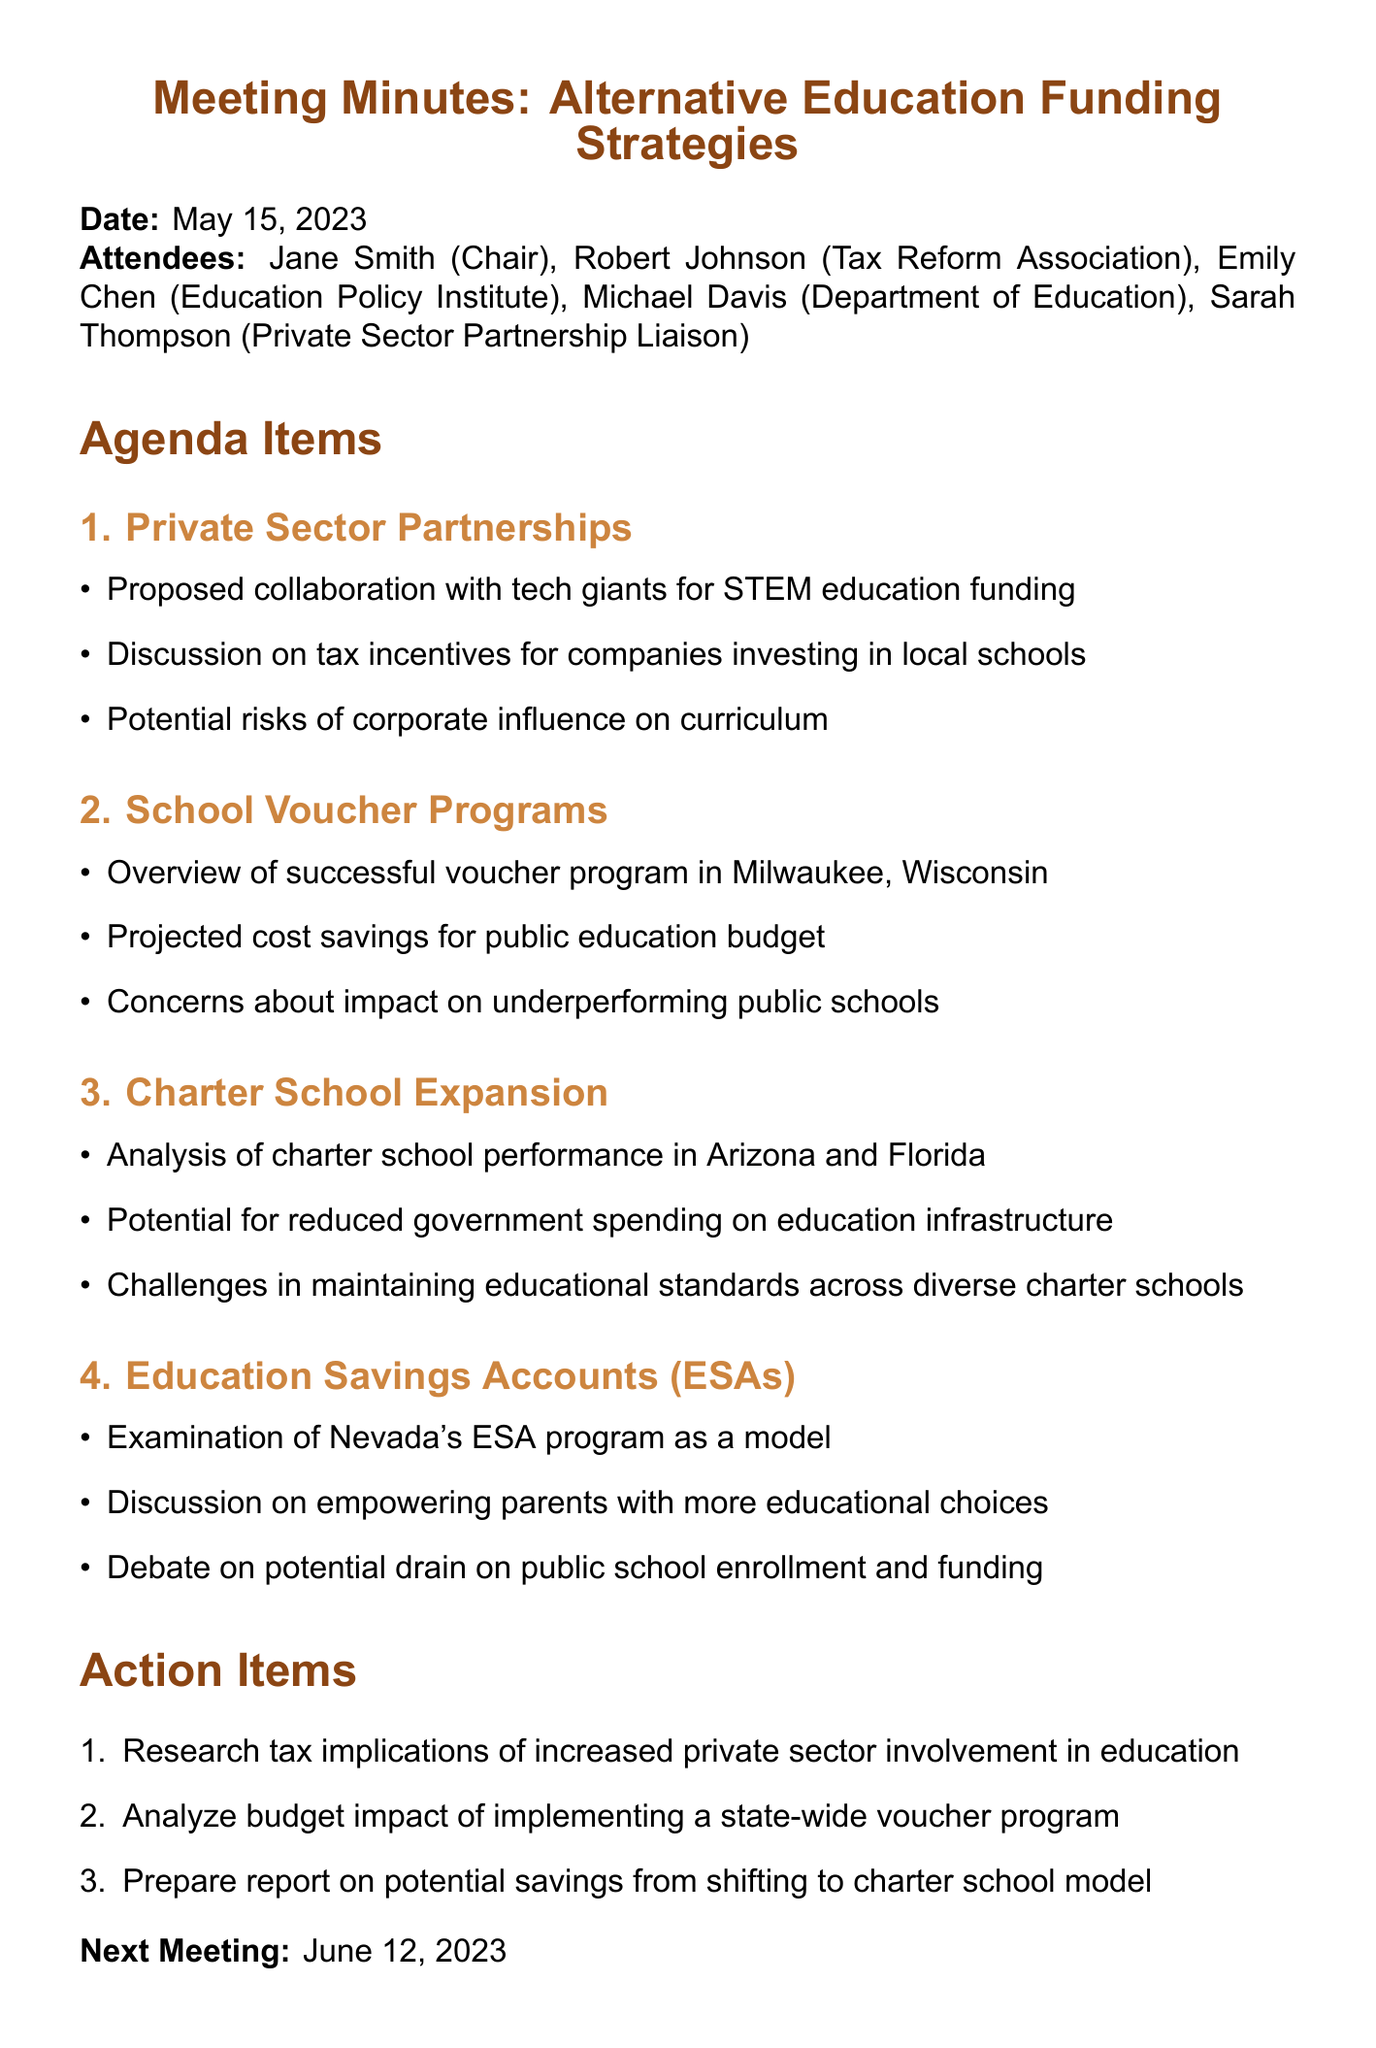What is the date of the meeting? The date of the meeting is stated clearly in the minutes.
Answer: May 15, 2023 Who is the chair of the meeting? The chair is mentioned in the list of attendees.
Answer: Jane Smith What is one of the proposed collaborations with tech companies? Specific proposals are listed under the Private Sector Partnerships section.
Answer: STEM education funding What successful voucher program is mentioned? Successful examples are provided in the School Voucher Programs section.
Answer: Milwaukee, Wisconsin What are the projected outcomes of the voucher program? The projected outcomes are noted in the key points of the School Voucher Programs discussion.
Answer: Cost savings for public education budget Which state’s ESA program is examined as a model? The meeting discusses specific examples in relation to Education Savings Accounts.
Answer: Nevada What did the attendees decide to research? The action items indicate the topics to be researched post-meeting.
Answer: Tax implications of increased private sector involvement What is one challenge mentioned about charter schools? Challenges are outlined in the Charter School Expansion key points.
Answer: Maintaining educational standards When is the next meeting scheduled? The date for the next meeting is listed at the end of the minutes.
Answer: June 12, 2023 